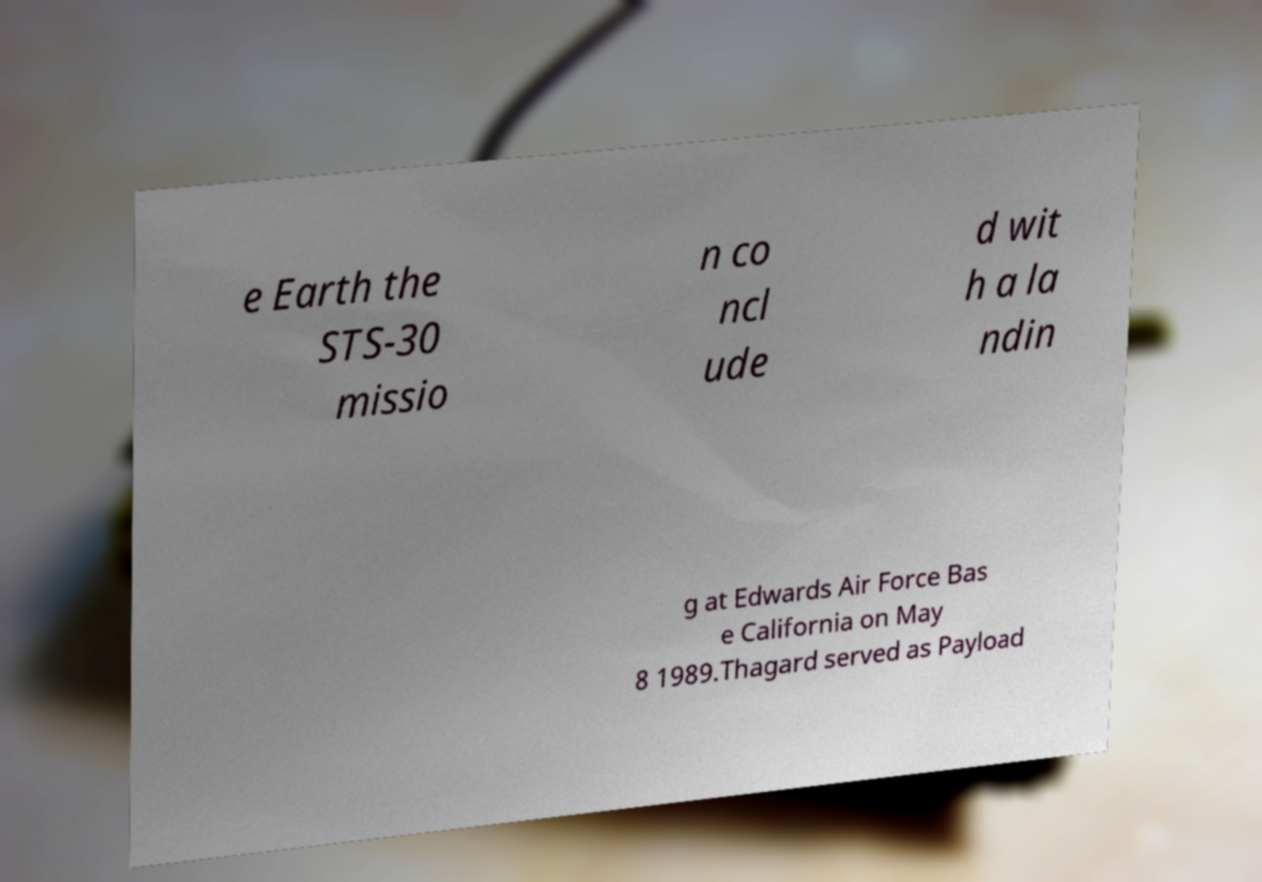What messages or text are displayed in this image? I need them in a readable, typed format. e Earth the STS-30 missio n co ncl ude d wit h a la ndin g at Edwards Air Force Bas e California on May 8 1989.Thagard served as Payload 